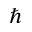Convert formula to latex. <formula><loc_0><loc_0><loc_500><loc_500>\hbar</formula> 